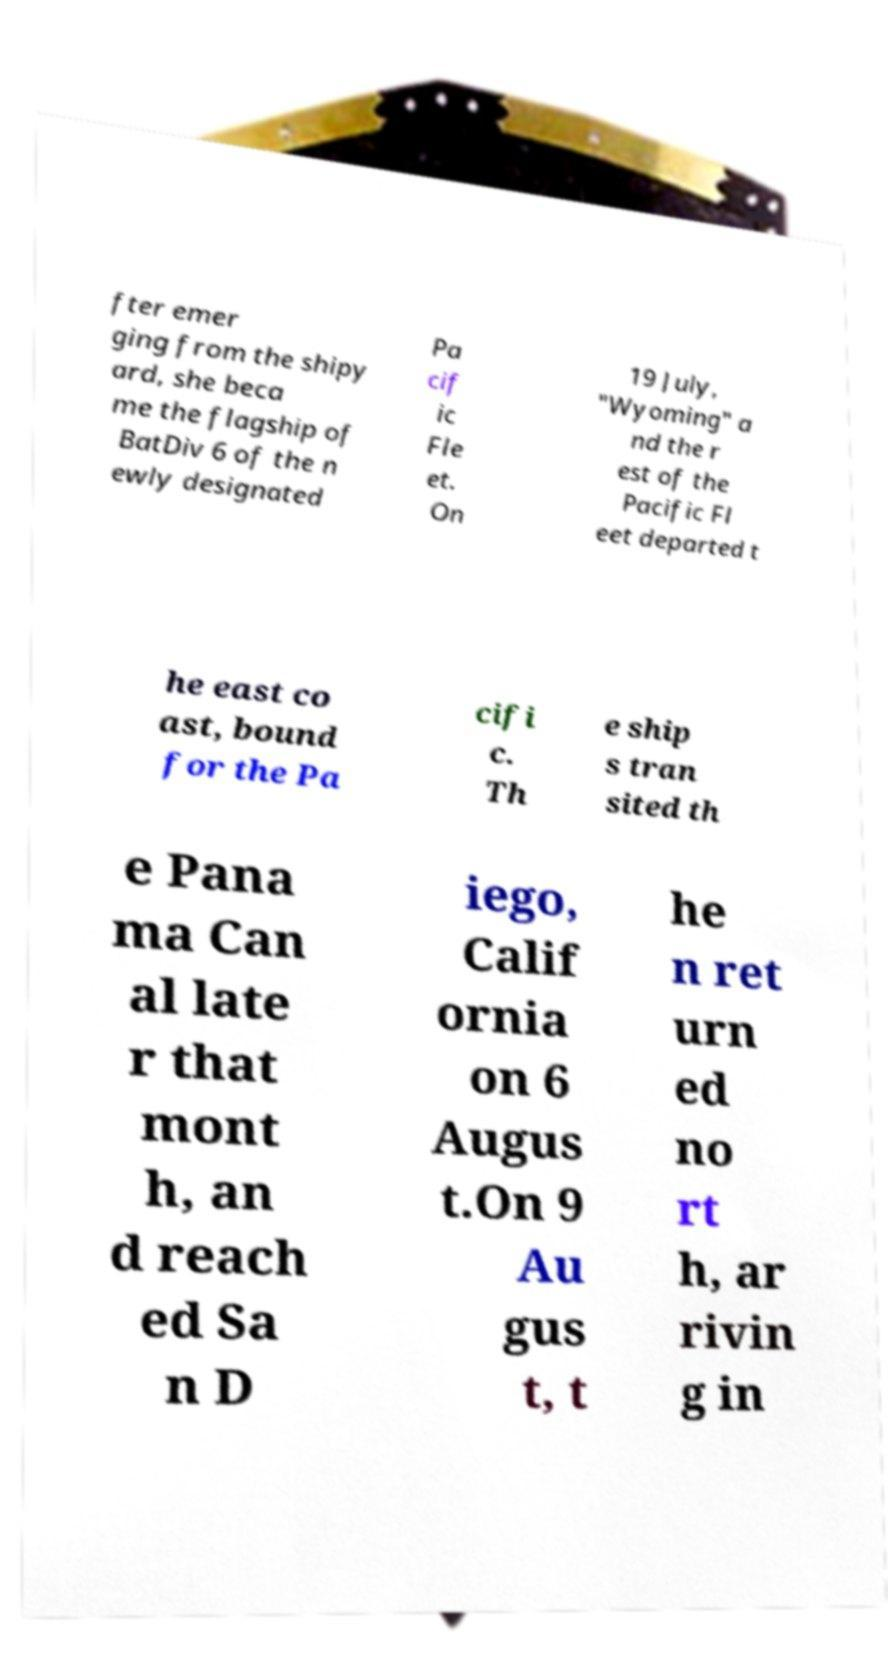Please read and relay the text visible in this image. What does it say? fter emer ging from the shipy ard, she beca me the flagship of BatDiv 6 of the n ewly designated Pa cif ic Fle et. On 19 July, "Wyoming" a nd the r est of the Pacific Fl eet departed t he east co ast, bound for the Pa cifi c. Th e ship s tran sited th e Pana ma Can al late r that mont h, an d reach ed Sa n D iego, Calif ornia on 6 Augus t.On 9 Au gus t, t he n ret urn ed no rt h, ar rivin g in 